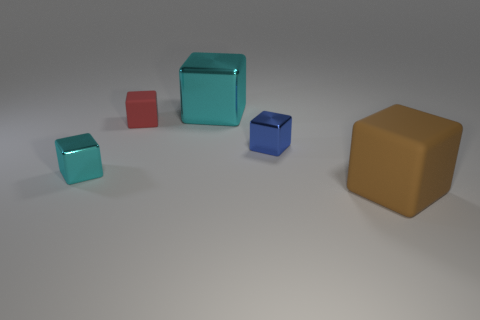Subtract all tiny red cubes. How many cubes are left? 4 Subtract all red blocks. How many blocks are left? 4 Subtract all gray cubes. Subtract all green balls. How many cubes are left? 5 Add 2 large brown shiny blocks. How many objects exist? 7 Add 4 large matte blocks. How many large matte blocks exist? 5 Subtract 0 yellow cylinders. How many objects are left? 5 Subtract all small blue objects. Subtract all large rubber things. How many objects are left? 3 Add 1 blue metallic cubes. How many blue metallic cubes are left? 2 